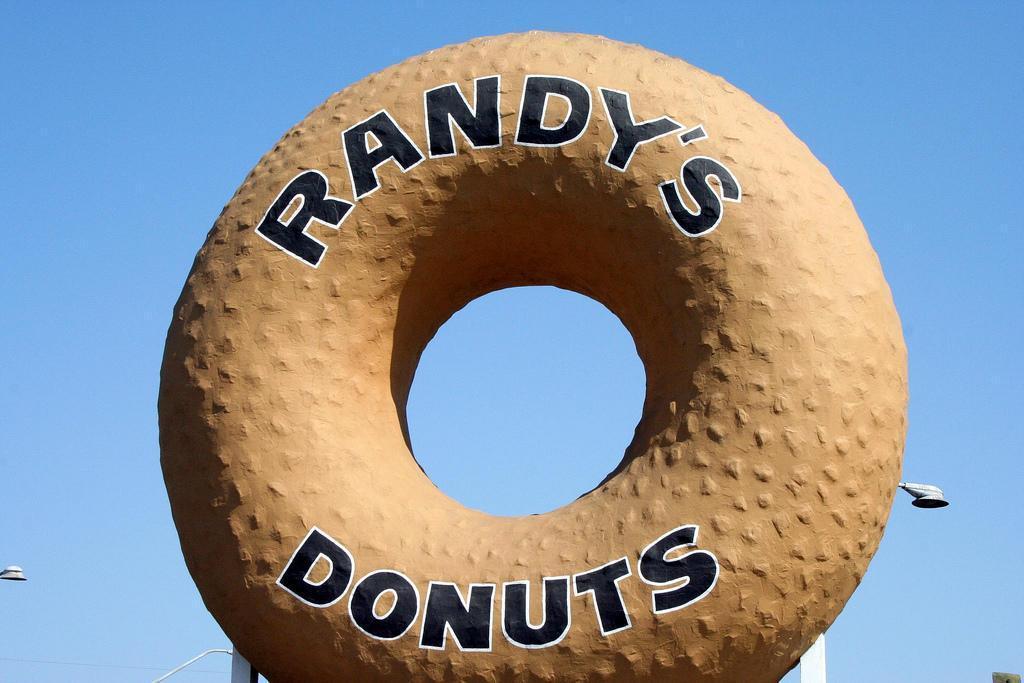How many words are printed on the sign?
Give a very brief answer. 2. 